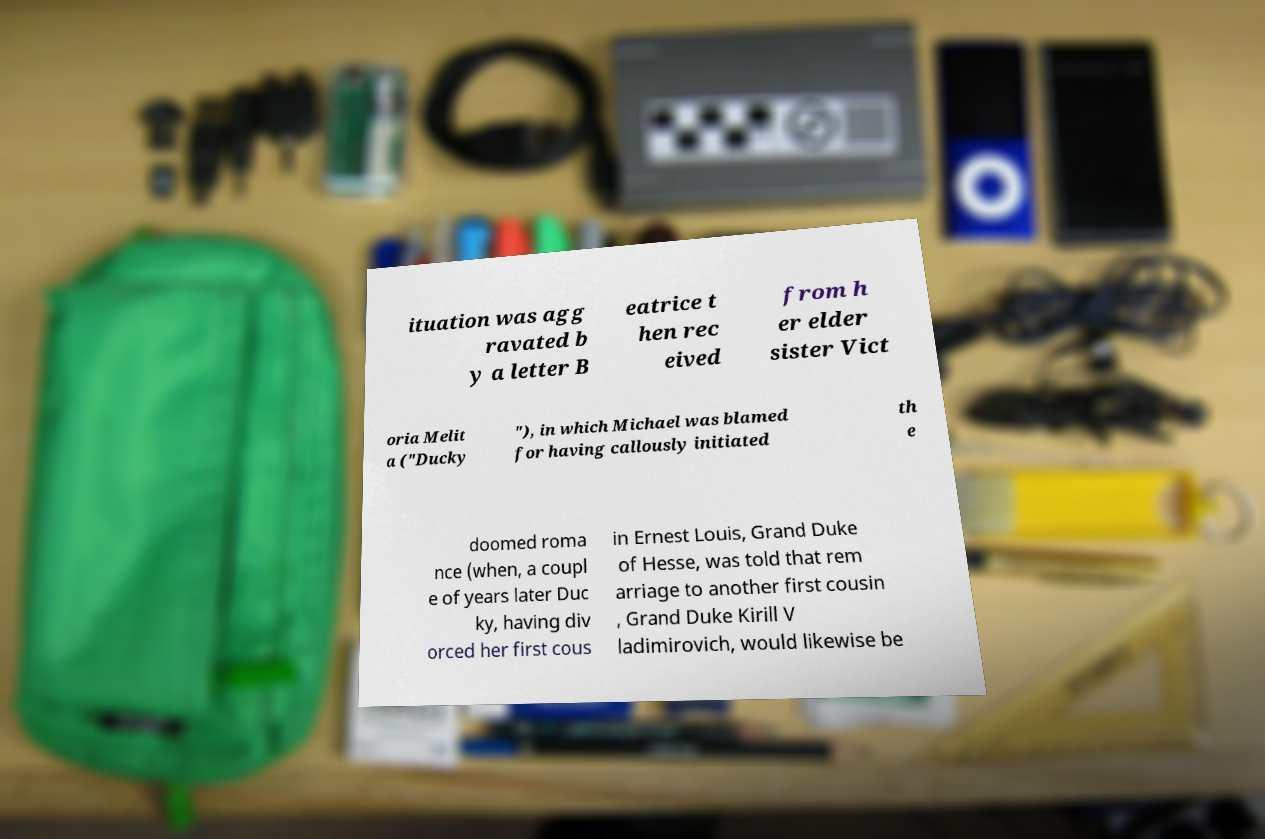For documentation purposes, I need the text within this image transcribed. Could you provide that? ituation was agg ravated b y a letter B eatrice t hen rec eived from h er elder sister Vict oria Melit a ("Ducky "), in which Michael was blamed for having callously initiated th e doomed roma nce (when, a coupl e of years later Duc ky, having div orced her first cous in Ernest Louis, Grand Duke of Hesse, was told that rem arriage to another first cousin , Grand Duke Kirill V ladimirovich, would likewise be 